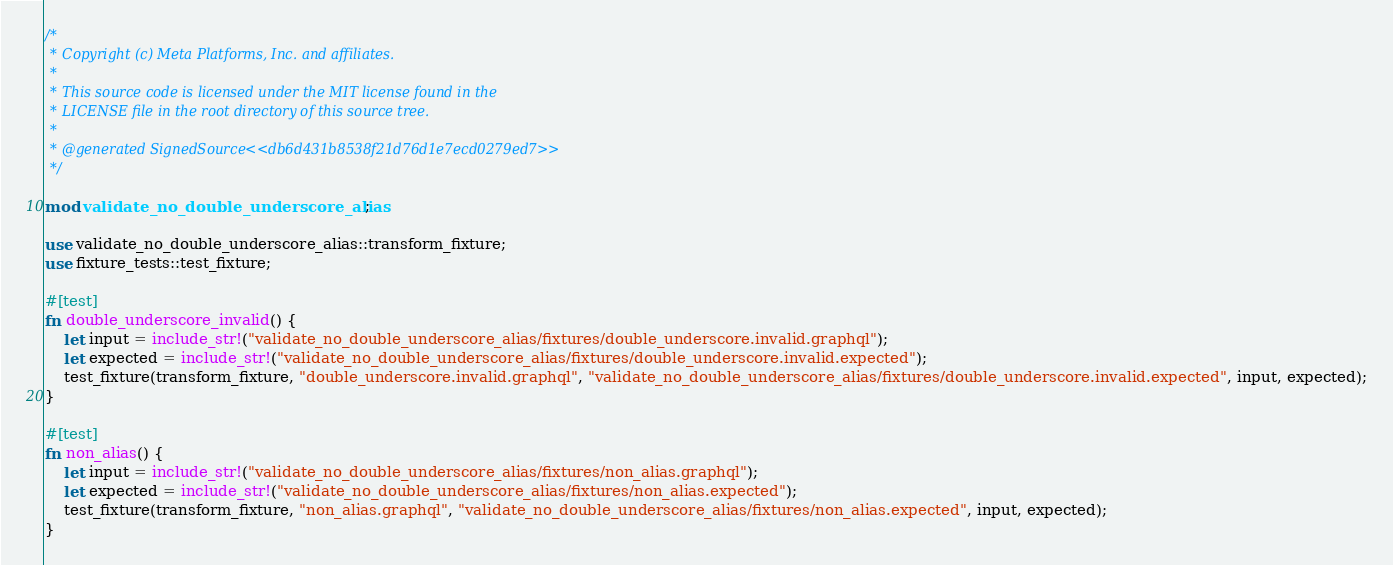Convert code to text. <code><loc_0><loc_0><loc_500><loc_500><_Rust_>/*
 * Copyright (c) Meta Platforms, Inc. and affiliates.
 *
 * This source code is licensed under the MIT license found in the
 * LICENSE file in the root directory of this source tree.
 *
 * @generated SignedSource<<db6d431b8538f21d76d1e7ecd0279ed7>>
 */

mod validate_no_double_underscore_alias;

use validate_no_double_underscore_alias::transform_fixture;
use fixture_tests::test_fixture;

#[test]
fn double_underscore_invalid() {
    let input = include_str!("validate_no_double_underscore_alias/fixtures/double_underscore.invalid.graphql");
    let expected = include_str!("validate_no_double_underscore_alias/fixtures/double_underscore.invalid.expected");
    test_fixture(transform_fixture, "double_underscore.invalid.graphql", "validate_no_double_underscore_alias/fixtures/double_underscore.invalid.expected", input, expected);
}

#[test]
fn non_alias() {
    let input = include_str!("validate_no_double_underscore_alias/fixtures/non_alias.graphql");
    let expected = include_str!("validate_no_double_underscore_alias/fixtures/non_alias.expected");
    test_fixture(transform_fixture, "non_alias.graphql", "validate_no_double_underscore_alias/fixtures/non_alias.expected", input, expected);
}
</code> 